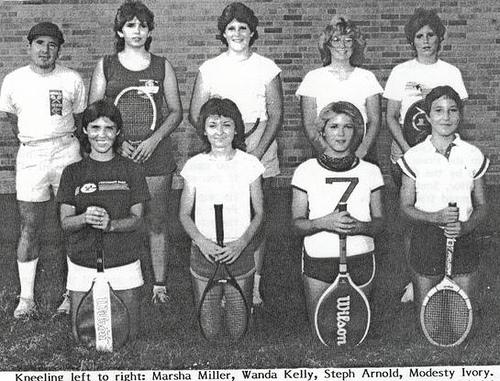How many people are in this photo?
Be succinct. 9. What kind of team is this?
Write a very short answer. Tennis. Is this a new photo?
Keep it brief. No. 